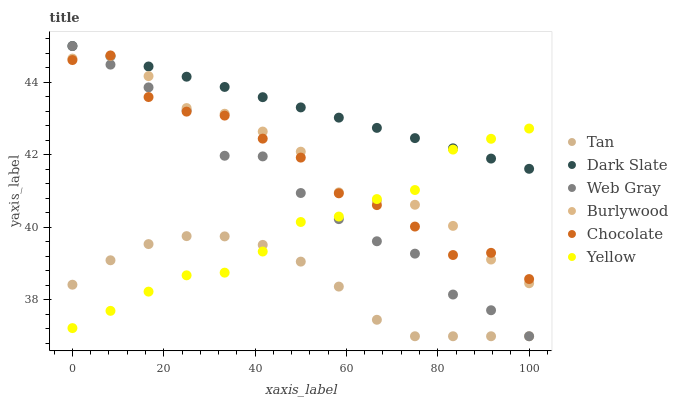Does Tan have the minimum area under the curve?
Answer yes or no. Yes. Does Dark Slate have the maximum area under the curve?
Answer yes or no. Yes. Does Burlywood have the minimum area under the curve?
Answer yes or no. No. Does Burlywood have the maximum area under the curve?
Answer yes or no. No. Is Dark Slate the smoothest?
Answer yes or no. Yes. Is Chocolate the roughest?
Answer yes or no. Yes. Is Burlywood the smoothest?
Answer yes or no. No. Is Burlywood the roughest?
Answer yes or no. No. Does Web Gray have the lowest value?
Answer yes or no. Yes. Does Burlywood have the lowest value?
Answer yes or no. No. Does Dark Slate have the highest value?
Answer yes or no. Yes. Does Burlywood have the highest value?
Answer yes or no. No. Is Tan less than Burlywood?
Answer yes or no. Yes. Is Dark Slate greater than Tan?
Answer yes or no. Yes. Does Yellow intersect Dark Slate?
Answer yes or no. Yes. Is Yellow less than Dark Slate?
Answer yes or no. No. Is Yellow greater than Dark Slate?
Answer yes or no. No. Does Tan intersect Burlywood?
Answer yes or no. No. 